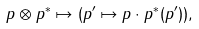Convert formula to latex. <formula><loc_0><loc_0><loc_500><loc_500>p \otimes p ^ { * } \mapsto ( p ^ { \prime } \mapsto p \cdot p ^ { * } ( p ^ { \prime } ) ) ,</formula> 